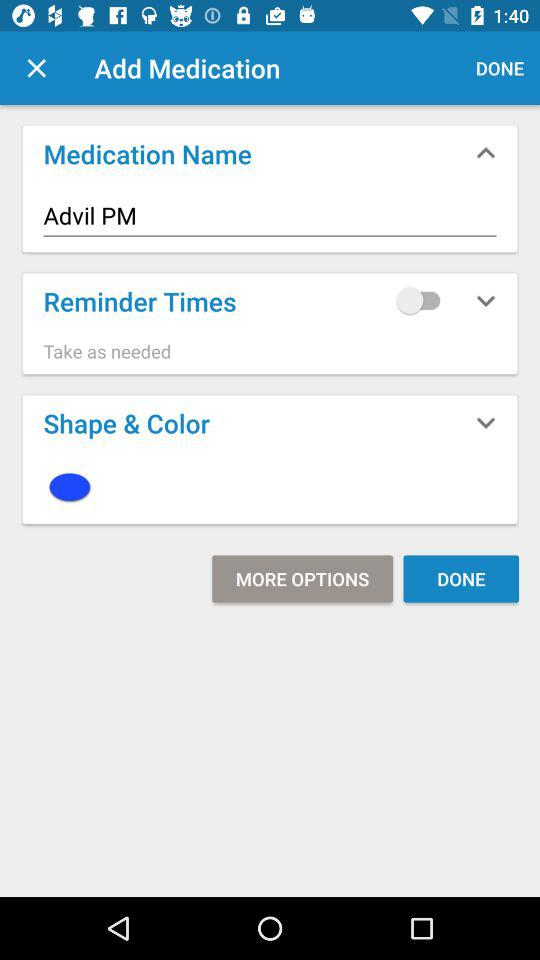Which is the selected color? The selected color is blue. 